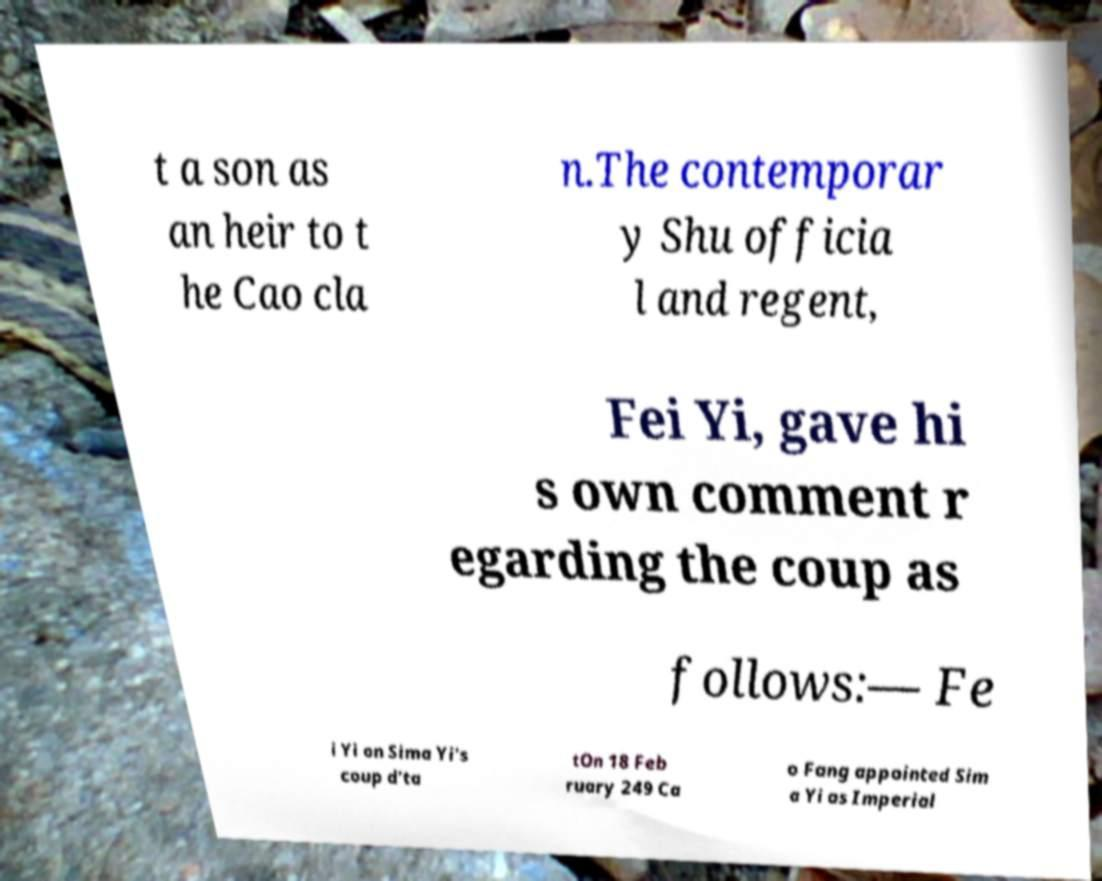Can you accurately transcribe the text from the provided image for me? t a son as an heir to t he Cao cla n.The contemporar y Shu officia l and regent, Fei Yi, gave hi s own comment r egarding the coup as follows:— Fe i Yi on Sima Yi's coup d'ta tOn 18 Feb ruary 249 Ca o Fang appointed Sim a Yi as Imperial 